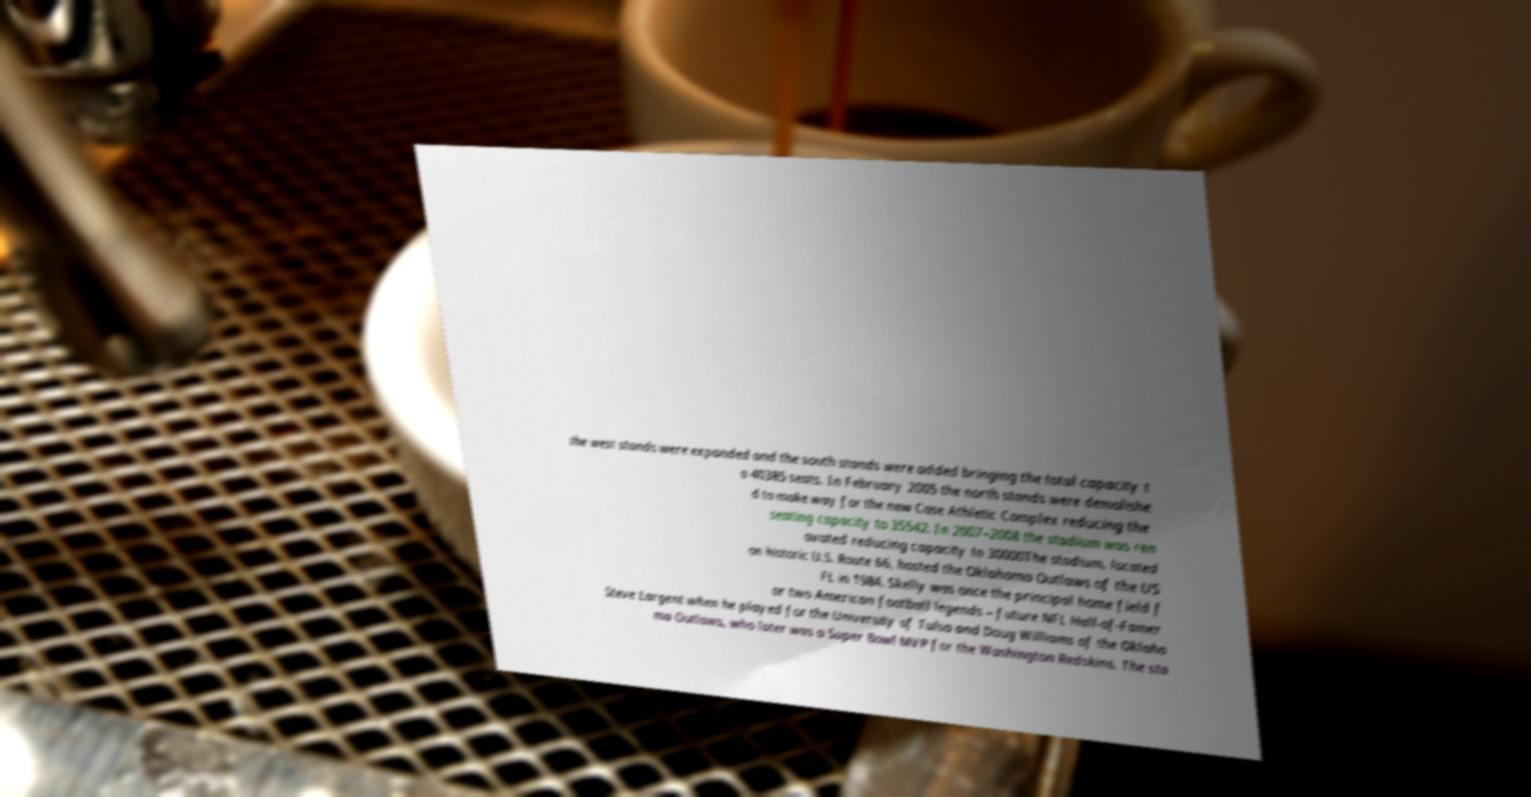For documentation purposes, I need the text within this image transcribed. Could you provide that? the west stands were expanded and the south stands were added bringing the total capacity t o 40385 seats. In February 2005 the north stands were demolishe d to make way for the new Case Athletic Complex reducing the seating capacity to 35542. In 2007–2008 the stadium was ren ovated reducing capacity to 30000The stadium, located on historic U.S. Route 66, hosted the Oklahoma Outlaws of the US FL in 1984. Skelly was once the principal home field f or two American football legends – future NFL Hall-of-Famer Steve Largent when he played for the University of Tulsa and Doug Williams of the Oklaho ma Outlaws, who later was a Super Bowl MVP for the Washington Redskins. The sta 